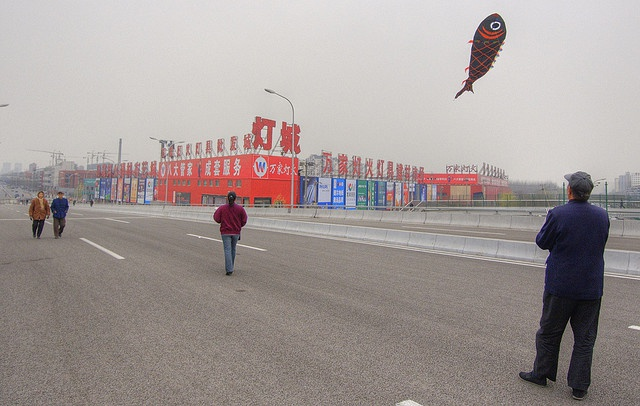Describe the objects in this image and their specific colors. I can see people in lightgray, black, gray, navy, and darkgray tones, kite in lightgray, gray, black, and maroon tones, people in lightgray, maroon, gray, black, and purple tones, people in lightgray, maroon, black, and gray tones, and people in lightgray, navy, black, and gray tones in this image. 